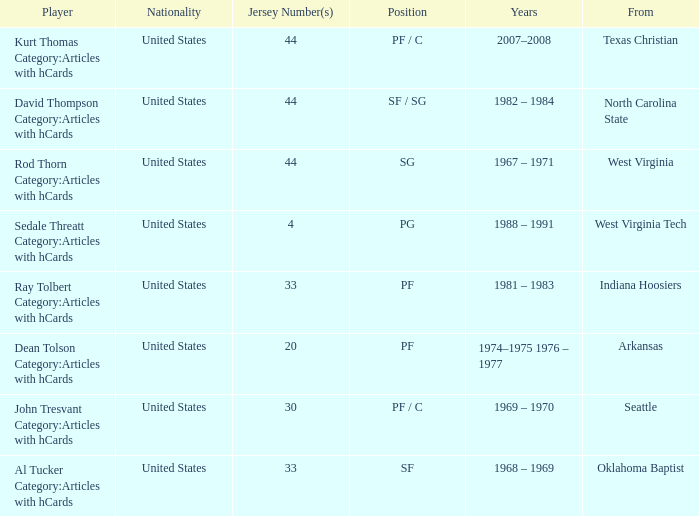From oklahoma baptist, what was the top jersey number assigned to a player? 33.0. 